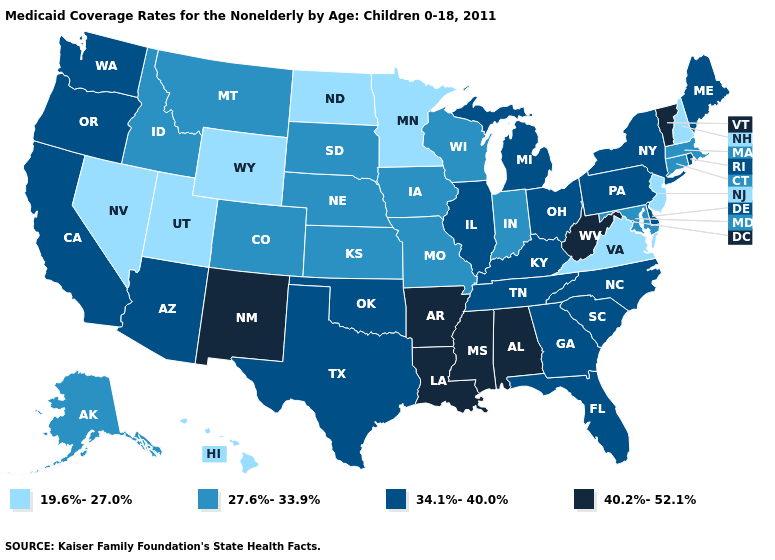Does Wisconsin have a higher value than Wyoming?
Concise answer only. Yes. Does Nevada have the lowest value in the USA?
Give a very brief answer. Yes. What is the value of Hawaii?
Keep it brief. 19.6%-27.0%. Name the states that have a value in the range 19.6%-27.0%?
Write a very short answer. Hawaii, Minnesota, Nevada, New Hampshire, New Jersey, North Dakota, Utah, Virginia, Wyoming. What is the value of Alaska?
Give a very brief answer. 27.6%-33.9%. What is the highest value in the Northeast ?
Give a very brief answer. 40.2%-52.1%. What is the value of Minnesota?
Give a very brief answer. 19.6%-27.0%. What is the value of Washington?
Quick response, please. 34.1%-40.0%. Among the states that border North Carolina , which have the lowest value?
Short answer required. Virginia. Which states have the lowest value in the USA?
Write a very short answer. Hawaii, Minnesota, Nevada, New Hampshire, New Jersey, North Dakota, Utah, Virginia, Wyoming. How many symbols are there in the legend?
Give a very brief answer. 4. Does New Jersey have the highest value in the Northeast?
Be succinct. No. Name the states that have a value in the range 27.6%-33.9%?
Concise answer only. Alaska, Colorado, Connecticut, Idaho, Indiana, Iowa, Kansas, Maryland, Massachusetts, Missouri, Montana, Nebraska, South Dakota, Wisconsin. Name the states that have a value in the range 19.6%-27.0%?
Short answer required. Hawaii, Minnesota, Nevada, New Hampshire, New Jersey, North Dakota, Utah, Virginia, Wyoming. What is the value of Oregon?
Quick response, please. 34.1%-40.0%. 